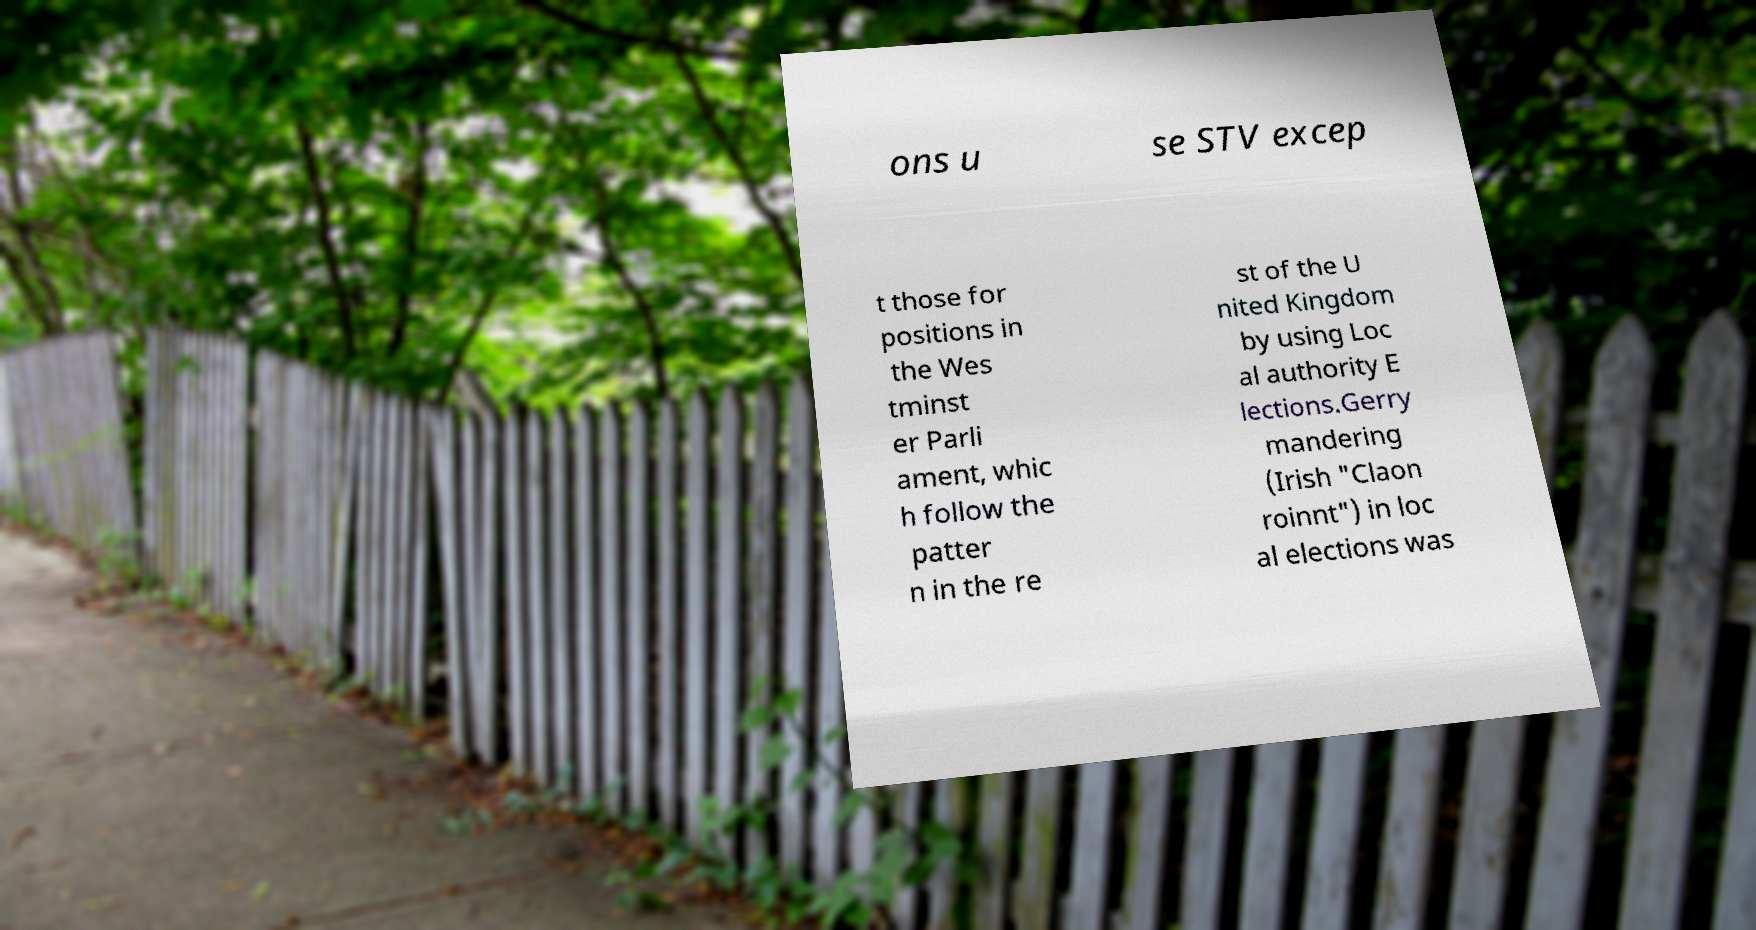What messages or text are displayed in this image? I need them in a readable, typed format. ons u se STV excep t those for positions in the Wes tminst er Parli ament, whic h follow the patter n in the re st of the U nited Kingdom by using Loc al authority E lections.Gerry mandering (Irish "Claon roinnt") in loc al elections was 